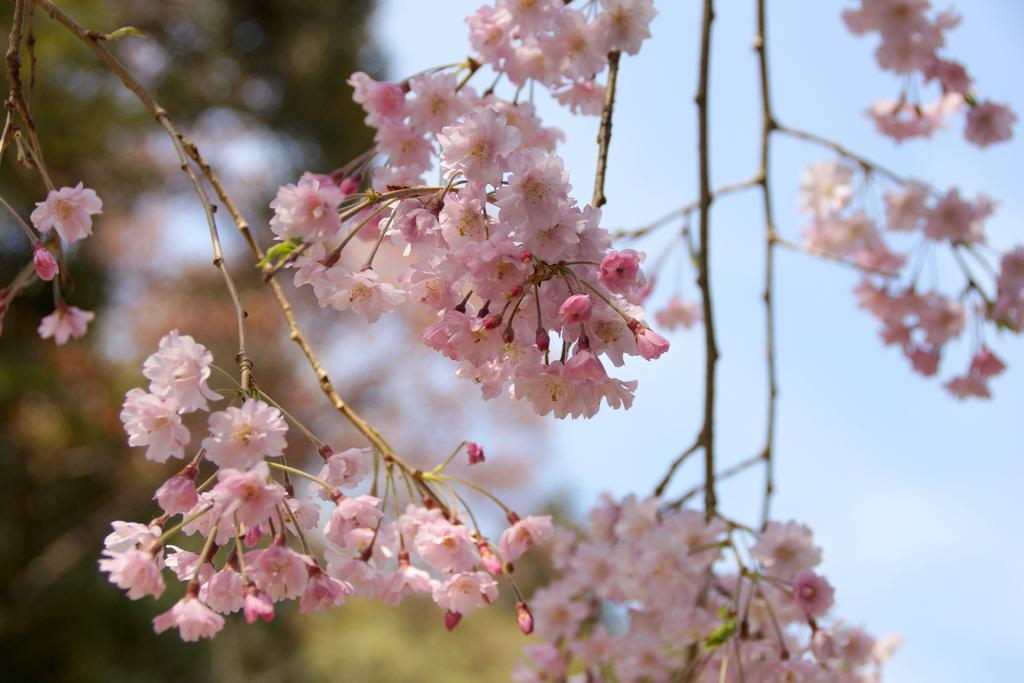What type of flowers are present in the image? There are pink color flowers in the image. What can be seen in the background of the image? The background of the image includes the sky. How would you describe the background of the image? The background of the image is blurred. What type of dock can be seen in the image? There is no dock present in the image; it features pink color flowers and a blurred background. What is being served for breakfast in the image? There is no reference to breakfast or any food items in the image. 